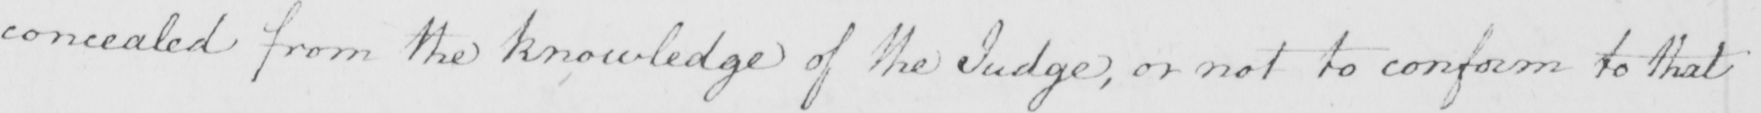What does this handwritten line say? concealed from the knowledge of the Judge , or not to conform to that 